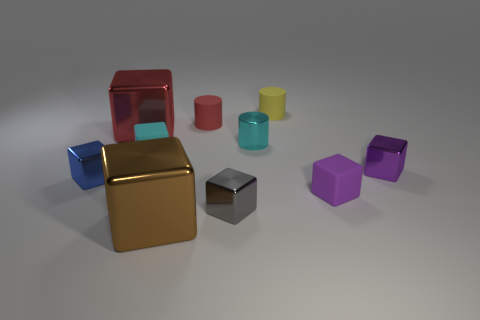Subtract all tiny matte blocks. How many blocks are left? 5 Subtract all purple cubes. How many cubes are left? 5 Subtract all brown cylinders. How many purple blocks are left? 2 Subtract 0 green cylinders. How many objects are left? 10 Subtract all blocks. How many objects are left? 3 Subtract 1 cylinders. How many cylinders are left? 2 Subtract all gray cylinders. Subtract all yellow blocks. How many cylinders are left? 3 Subtract all large cyan matte cylinders. Subtract all tiny blue shiny things. How many objects are left? 9 Add 2 purple metallic objects. How many purple metallic objects are left? 3 Add 7 large brown things. How many large brown things exist? 8 